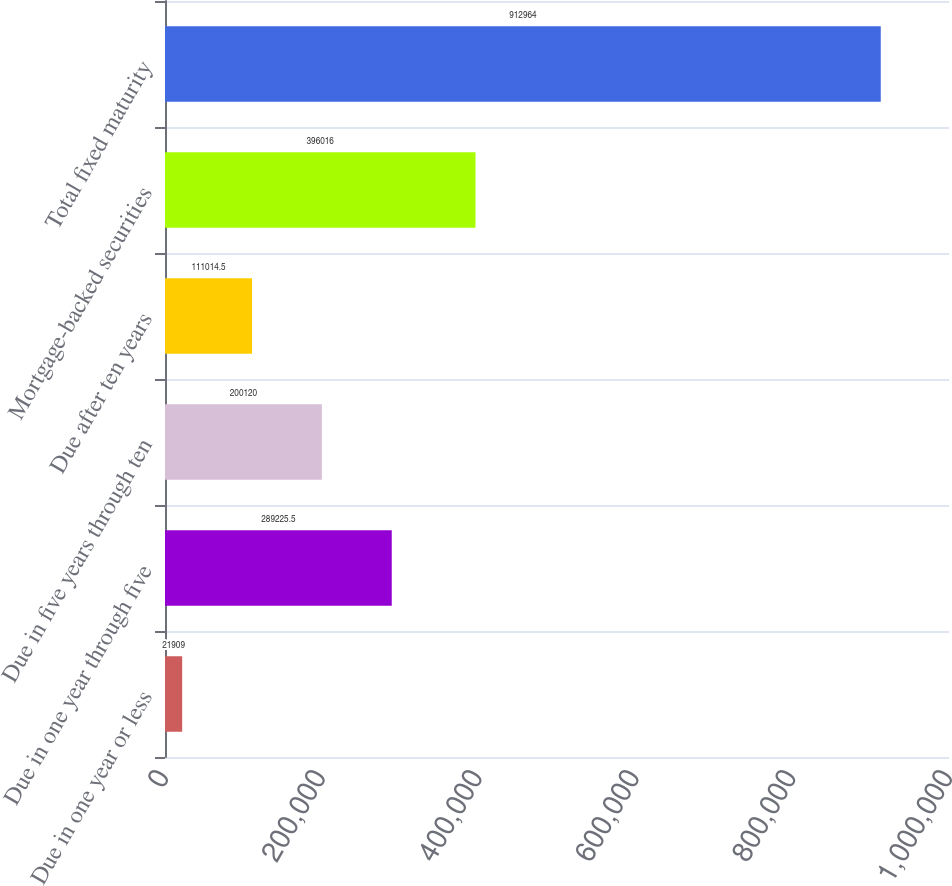Convert chart. <chart><loc_0><loc_0><loc_500><loc_500><bar_chart><fcel>Due in one year or less<fcel>Due in one year through five<fcel>Due in five years through ten<fcel>Due after ten years<fcel>Mortgage-backed securities<fcel>Total fixed maturity<nl><fcel>21909<fcel>289226<fcel>200120<fcel>111014<fcel>396016<fcel>912964<nl></chart> 